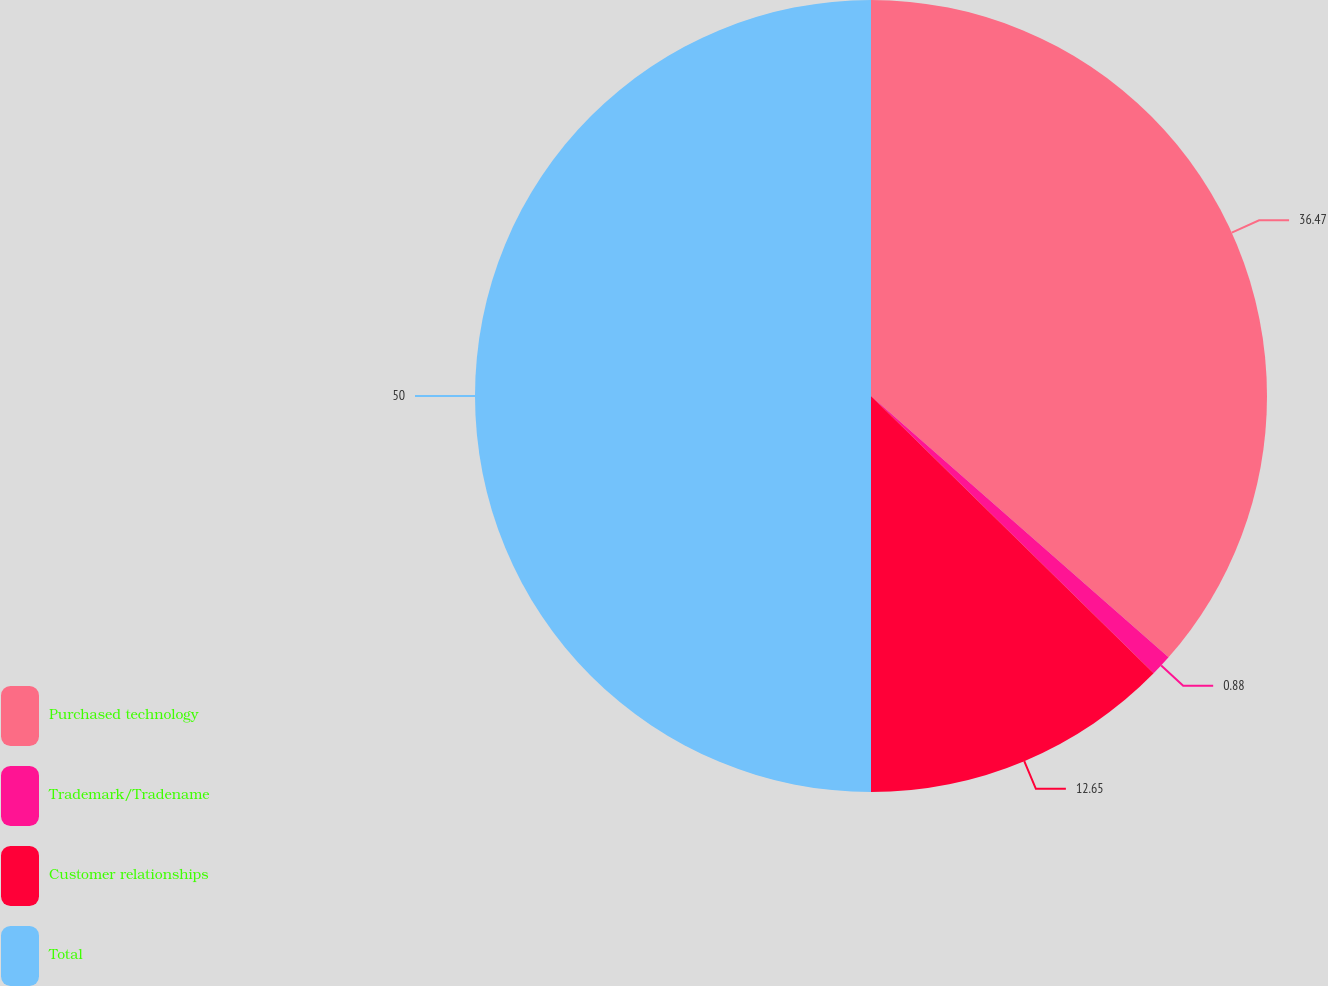Convert chart to OTSL. <chart><loc_0><loc_0><loc_500><loc_500><pie_chart><fcel>Purchased technology<fcel>Trademark/Tradename<fcel>Customer relationships<fcel>Total<nl><fcel>36.47%<fcel>0.88%<fcel>12.65%<fcel>50.0%<nl></chart> 